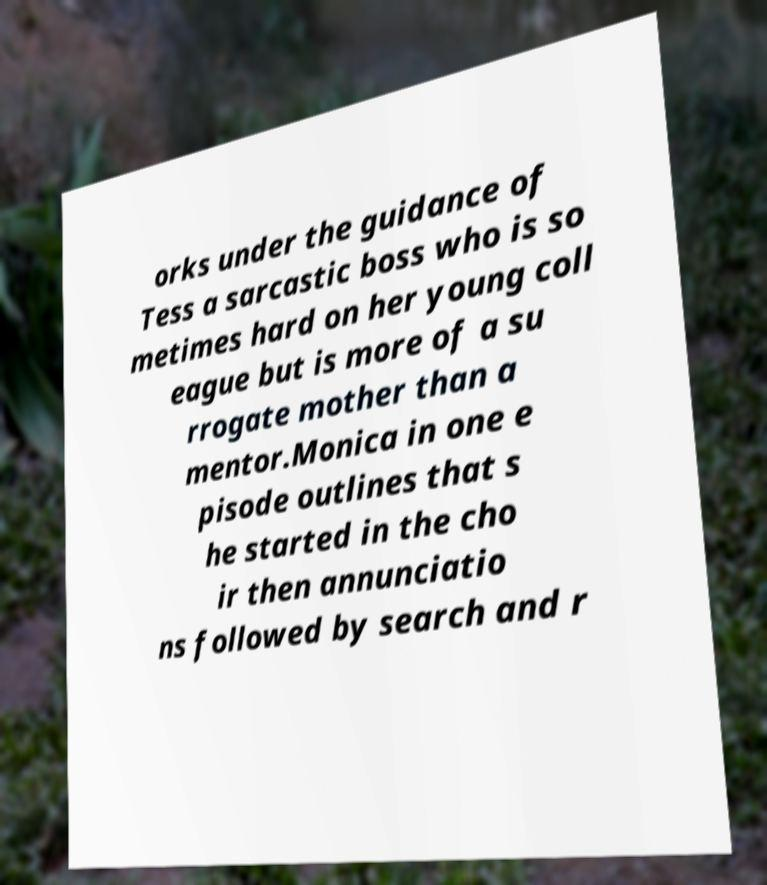Could you extract and type out the text from this image? orks under the guidance of Tess a sarcastic boss who is so metimes hard on her young coll eague but is more of a su rrogate mother than a mentor.Monica in one e pisode outlines that s he started in the cho ir then annunciatio ns followed by search and r 